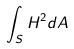Convert formula to latex. <formula><loc_0><loc_0><loc_500><loc_500>\int _ { S } H ^ { 2 } d A</formula> 